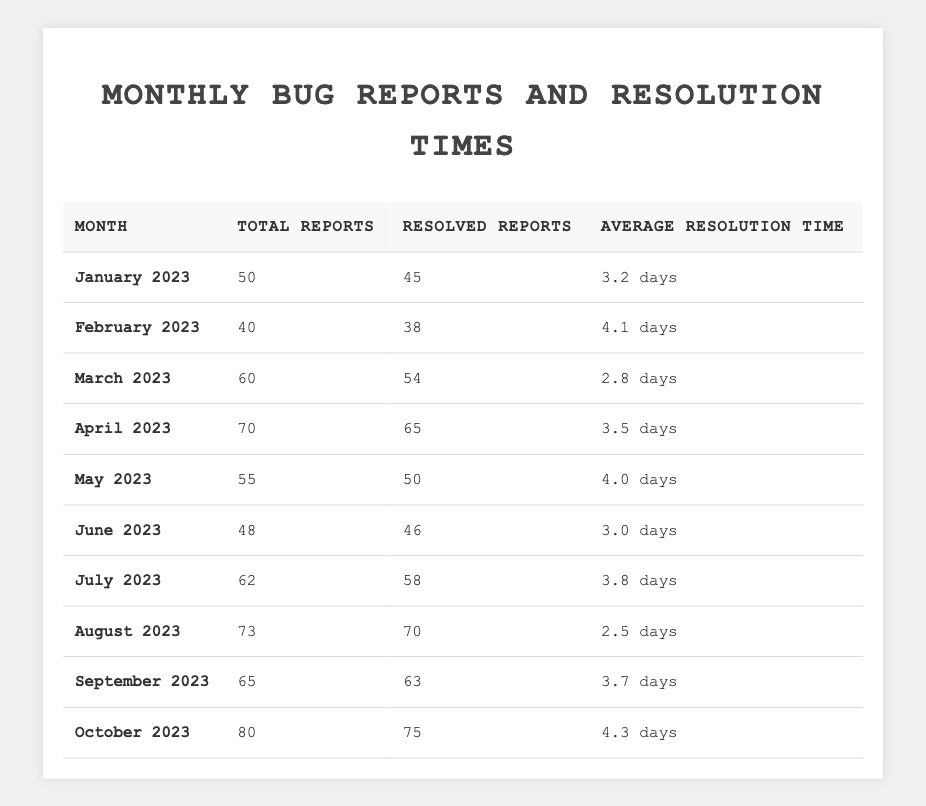What was the total number of bug reports in March 2023? The table shows that in March 2023, the total number of bug reports was listed as 60.
Answer: 60 How many bug reports were resolved in June 2023? According to the table, June 2023 had 46 resolved reports.
Answer: 46 What was the average resolution time for bug reports in April 2023? The table indicates that the average resolution time for April 2023 was 3.5 days.
Answer: 3.5 days In which month was the highest total number of bug reports recorded? By inspecting the table, October 2023 had the highest total number of bug reports at 80.
Answer: October 2023 What is the difference in resolved reports between January and February 2023? January had 45 resolved reports, while February had 38. The difference is 45 - 38 = 7 resolved reports.
Answer: 7 What was the average number of resolved reports for the months of May and July 2023? May had 50 resolved reports and July had 58. The average is (50 + 58) / 2 = 54 resolved reports.
Answer: 54 Was there any month where the average resolution time was less than 3 days? Yes, the table shows that August 2023 had an average resolution time of 2.5 days, which is less than 3 days.
Answer: Yes Which month had the best average resolution time, and what was it? August 2023 had the best average resolution time at 2.5 days, as it is the lowest in the table.
Answer: August 2023, 2.5 days How many total bug reports were there from January to March 2023 combined? Summing the totals: January (50) + February (40) + March (60) = 150 total bug reports.
Answer: 150 What was the trend in the average resolution times from January to October 2023? Analyzing the table, the average resolution times fluctuated, with January at 3.2 days, peaking at 4.3 days in October. Overall, it increased but had several variations in between.
Answer: Fluctuating trend with an overall increase 